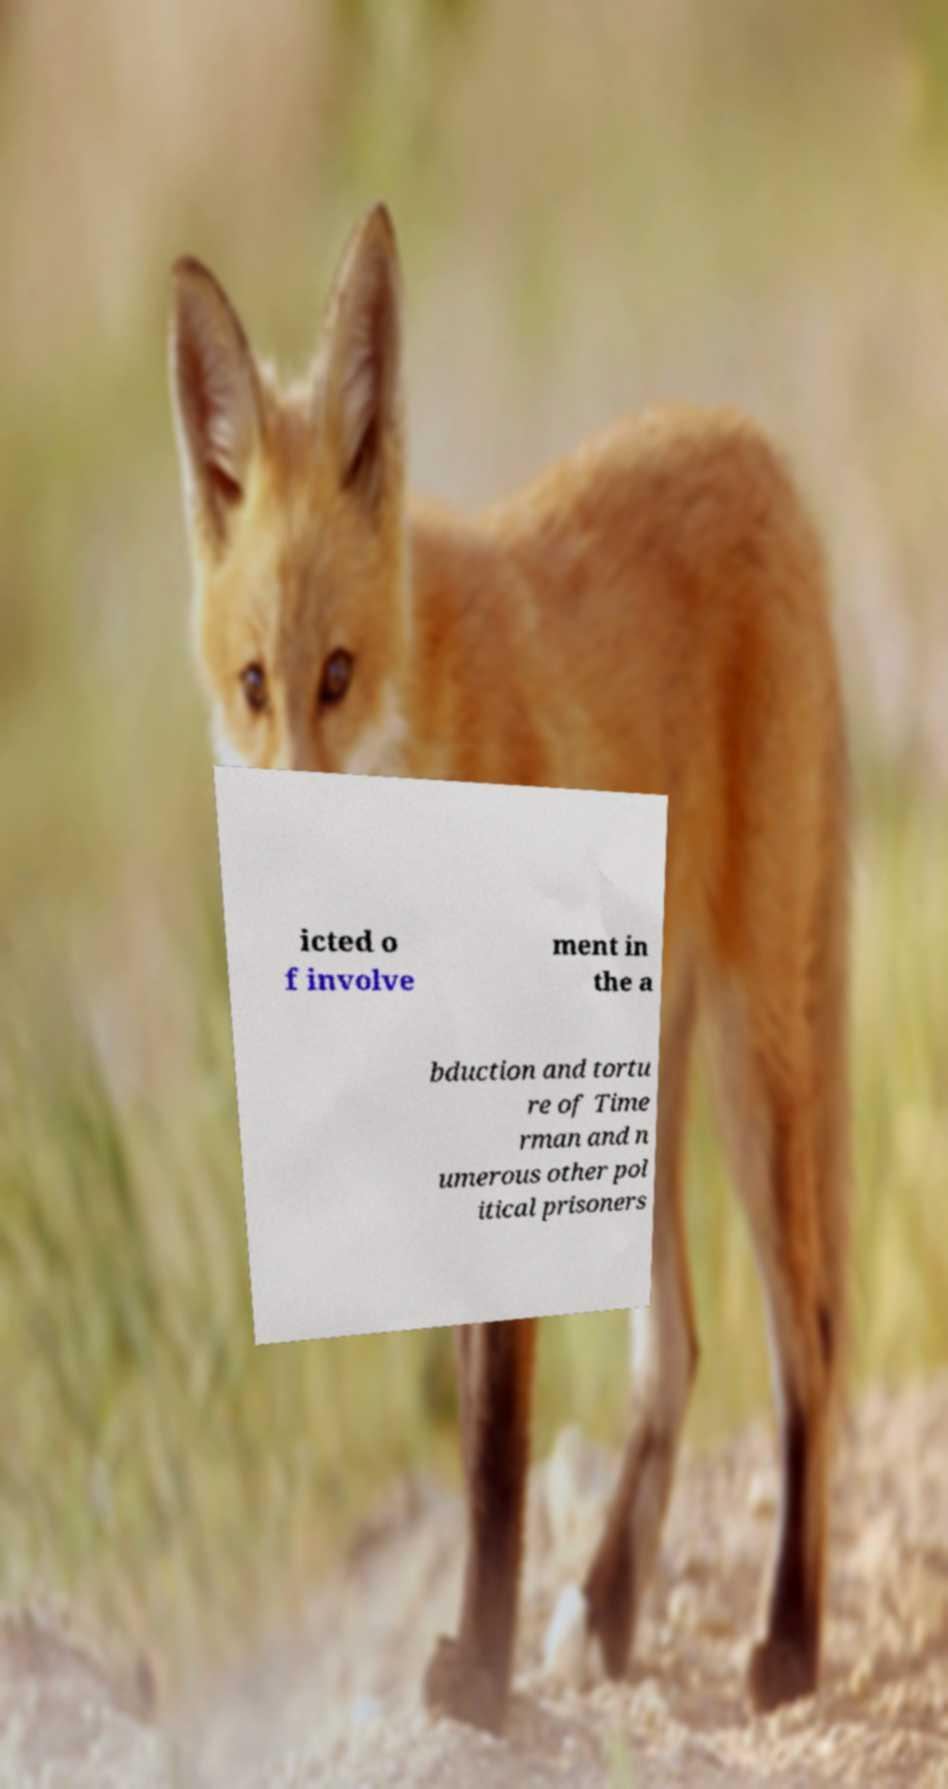Can you accurately transcribe the text from the provided image for me? icted o f involve ment in the a bduction and tortu re of Time rman and n umerous other pol itical prisoners 